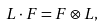Convert formula to latex. <formula><loc_0><loc_0><loc_500><loc_500>L \cdot F = F \otimes L ,</formula> 